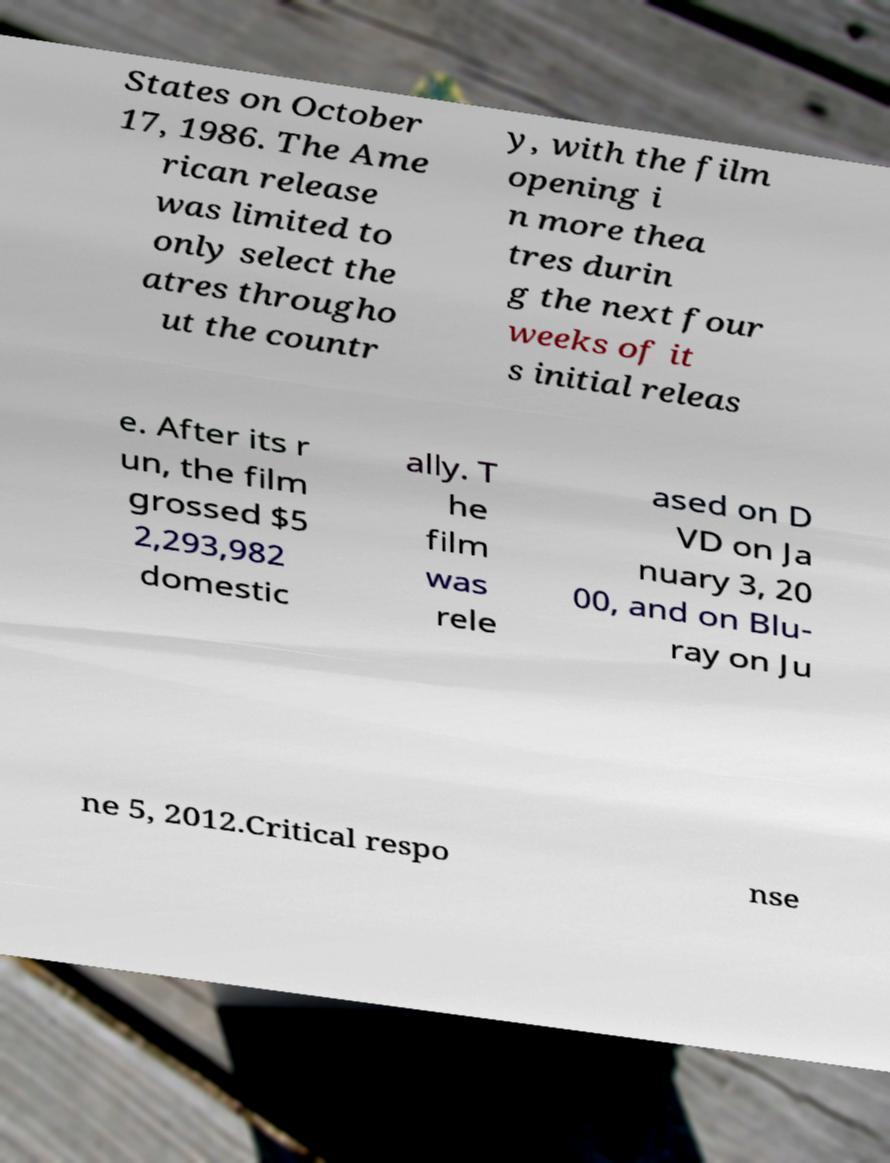What messages or text are displayed in this image? I need them in a readable, typed format. States on October 17, 1986. The Ame rican release was limited to only select the atres througho ut the countr y, with the film opening i n more thea tres durin g the next four weeks of it s initial releas e. After its r un, the film grossed $5 2,293,982 domestic ally. T he film was rele ased on D VD on Ja nuary 3, 20 00, and on Blu- ray on Ju ne 5, 2012.Critical respo nse 